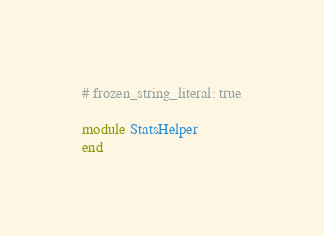Convert code to text. <code><loc_0><loc_0><loc_500><loc_500><_Ruby_># frozen_string_literal: true

module StatsHelper
end
</code> 